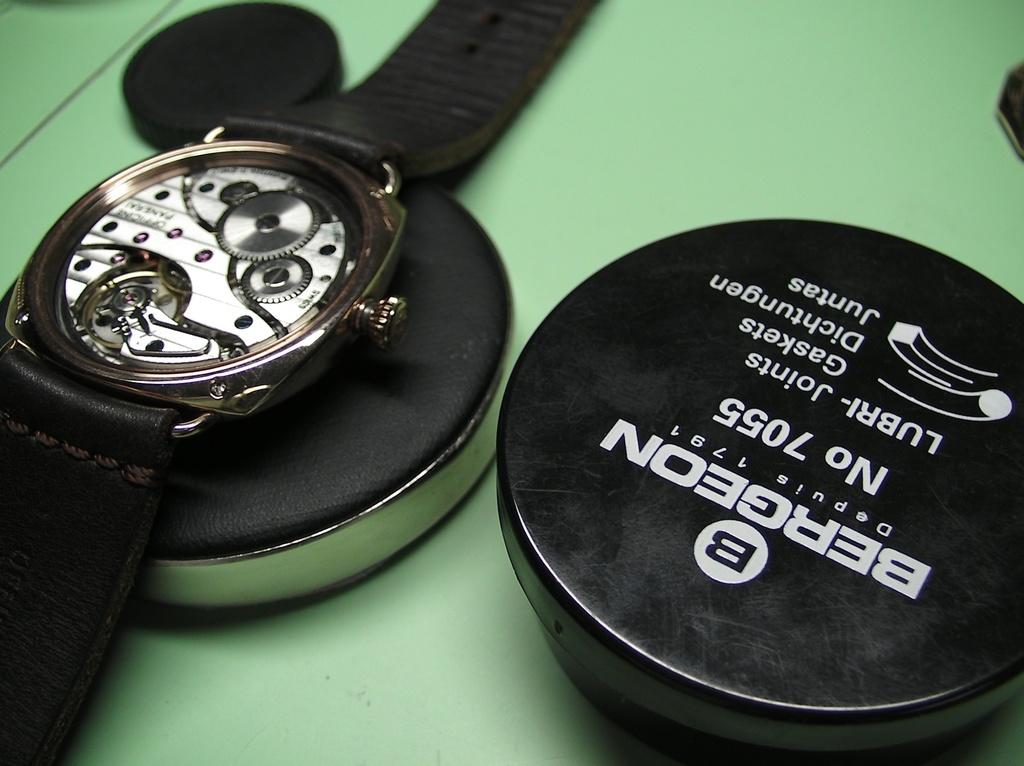What is the brand name of this watch?
Provide a succinct answer. Bergeon. What number is on the black case on the right?
Offer a very short reply. 7055. 